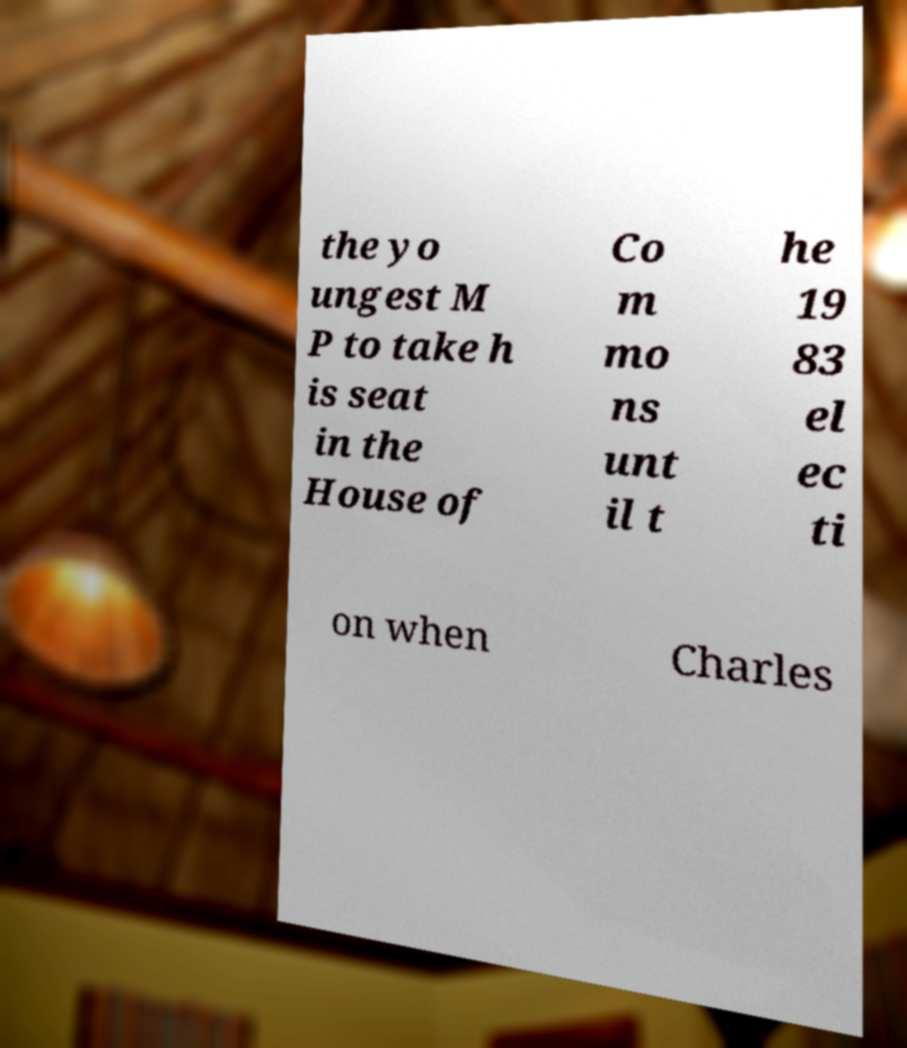I need the written content from this picture converted into text. Can you do that? the yo ungest M P to take h is seat in the House of Co m mo ns unt il t he 19 83 el ec ti on when Charles 